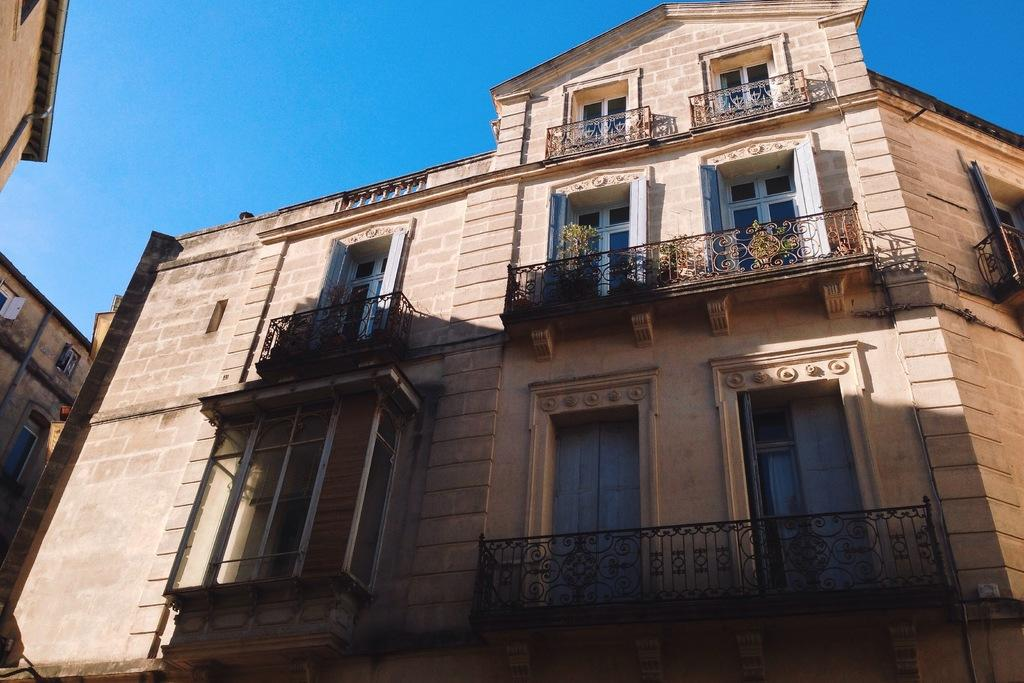What type of structures can be seen in the image? There are buildings in the image. What feature is visible on the buildings? There are windows visible in the image. What type of vegetation is present in the image? There are plants in the image. What effect can be observed on the objects in the image? Shadows are present in the image. What part of the natural environment is visible in the image? The sky is visible in the image. What type of twig can be seen in the image? There is no twig present in the image. Where is the mailbox located in the image? There is no mailbox present in the image. 